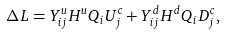Convert formula to latex. <formula><loc_0><loc_0><loc_500><loc_500>\Delta L = Y _ { i j } ^ { u } H ^ { u } Q _ { i } U _ { j } ^ { c } + Y _ { i j } ^ { d } H ^ { d } Q _ { i } D _ { j } ^ { c } ,</formula> 